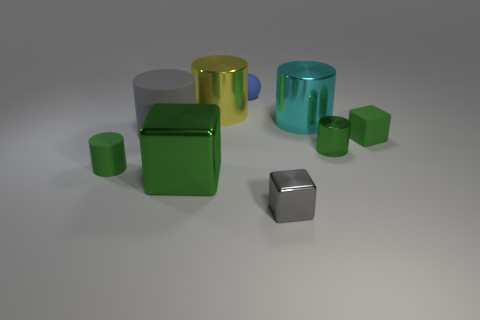Add 1 cubes. How many objects exist? 10 Subtract all large cylinders. How many cylinders are left? 2 Subtract all cyan cylinders. How many cylinders are left? 4 Subtract all cubes. How many objects are left? 6 Subtract 3 blocks. How many blocks are left? 0 Subtract all purple balls. Subtract all gray cylinders. How many balls are left? 1 Subtract all brown balls. How many cyan cylinders are left? 1 Subtract all red balls. Subtract all blue spheres. How many objects are left? 8 Add 4 tiny shiny objects. How many tiny shiny objects are left? 6 Add 3 large rubber cylinders. How many large rubber cylinders exist? 4 